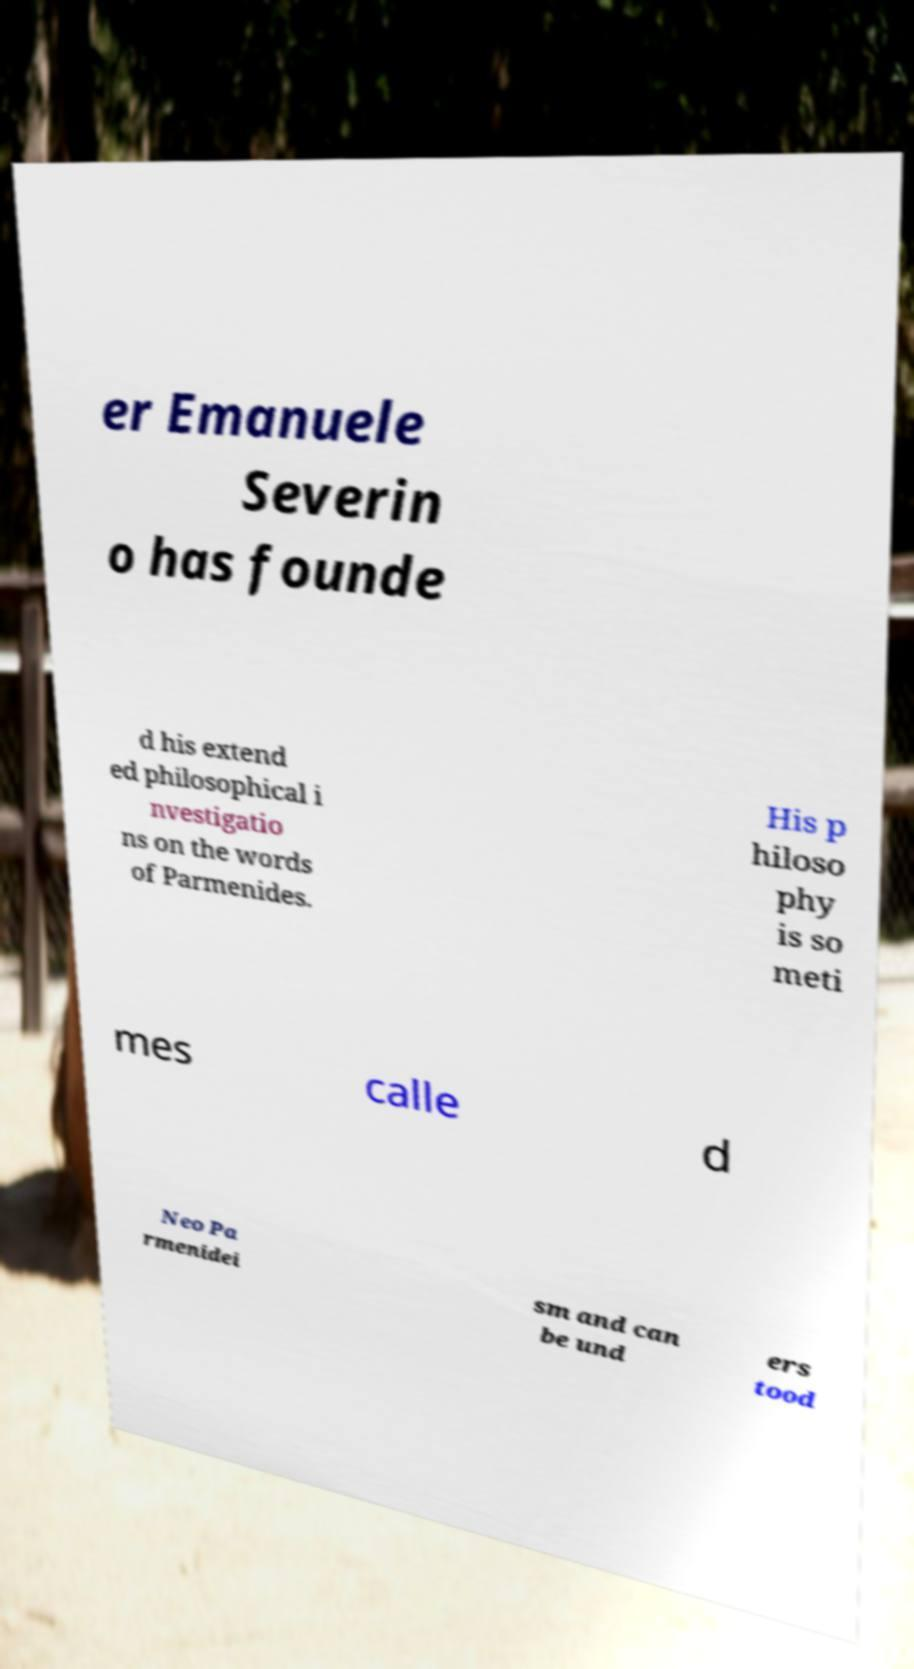Could you extract and type out the text from this image? er Emanuele Severin o has founde d his extend ed philosophical i nvestigatio ns on the words of Parmenides. His p hiloso phy is so meti mes calle d Neo Pa rmenidei sm and can be und ers tood 